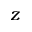<formula> <loc_0><loc_0><loc_500><loc_500>z</formula> 